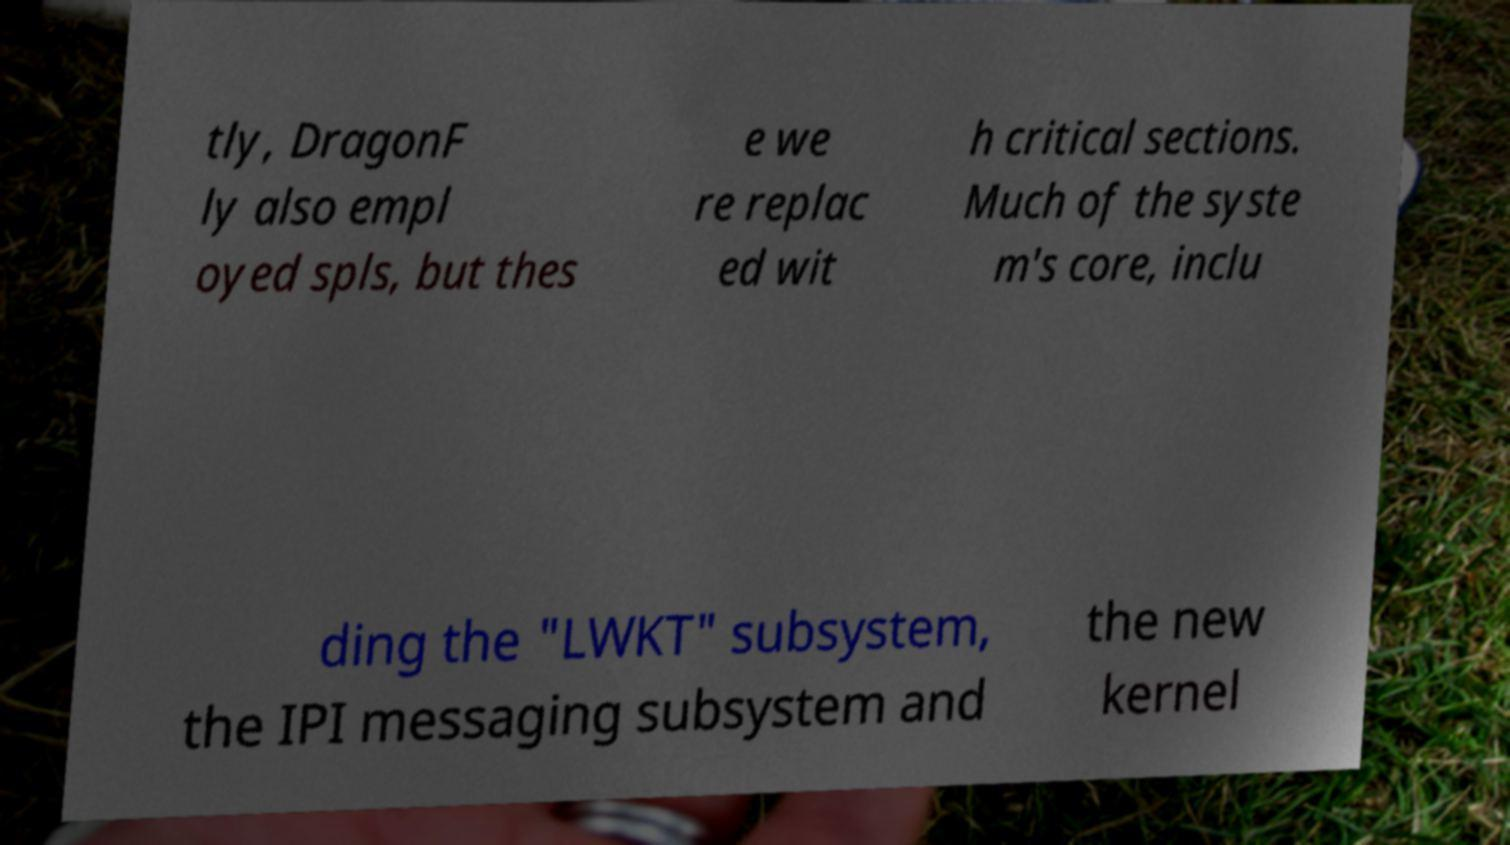Please identify and transcribe the text found in this image. tly, DragonF ly also empl oyed spls, but thes e we re replac ed wit h critical sections. Much of the syste m's core, inclu ding the "LWKT" subsystem, the IPI messaging subsystem and the new kernel 